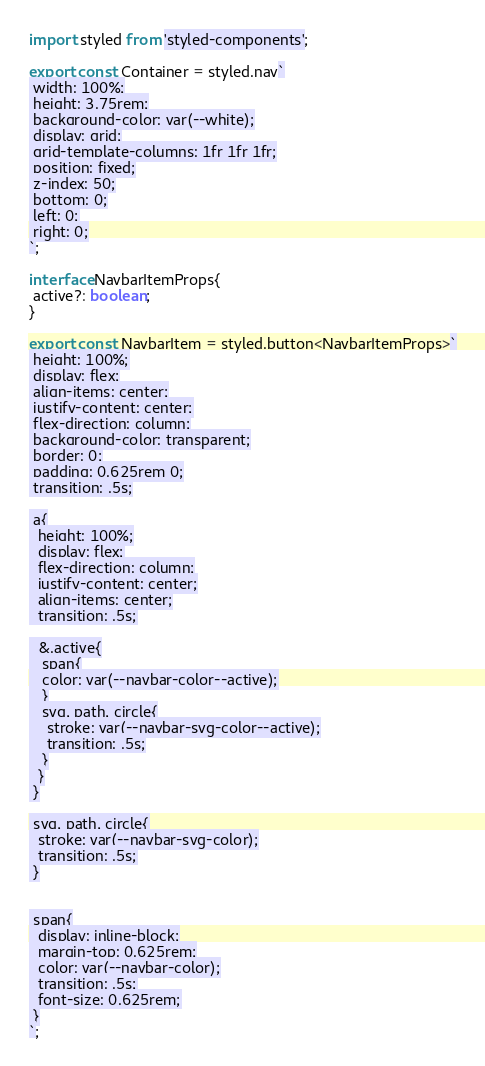<code> <loc_0><loc_0><loc_500><loc_500><_TypeScript_>import styled from 'styled-components';

export const Container = styled.nav`
 width: 100%;
 height: 3.75rem;
 background-color: var(--white);
 display: grid;
 grid-template-columns: 1fr 1fr 1fr;
 position: fixed;
 z-index: 50;
 bottom: 0;
 left: 0;
 right: 0;
`;

interface NavbarItemProps{
 active?: boolean;
}

export const NavbarItem = styled.button<NavbarItemProps>`
 height: 100%;
 display: flex;
 align-items: center;
 justify-content: center;
 flex-direction: column;
 background-color: transparent;
 border: 0;
 padding: 0.625rem 0;
 transition: .5s;

 a{
  height: 100%;
  display: flex;
  flex-direction: column;
  justify-content: center;
  align-items: center;
  transition: .5s;

  &.active{
   span{
   color: var(--navbar-color--active);
   }
   svg, path, circle{
    stroke: var(--navbar-svg-color--active);
    transition: .5s;
   }
  }
 }

 svg, path, circle{
  stroke: var(--navbar-svg-color);
  transition: .5s;
 }


 span{
  display: inline-block;
  margin-top: 0.625rem;
  color: var(--navbar-color);
  transition: .5s;
  font-size: 0.625rem;
 }
`;</code> 